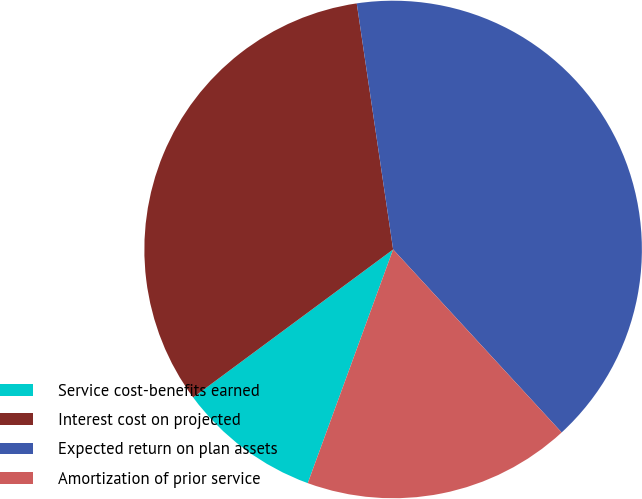Convert chart. <chart><loc_0><loc_0><loc_500><loc_500><pie_chart><fcel>Service cost-benefits earned<fcel>Interest cost on projected<fcel>Expected return on plan assets<fcel>Amortization of prior service<nl><fcel>9.29%<fcel>32.8%<fcel>40.49%<fcel>17.42%<nl></chart> 